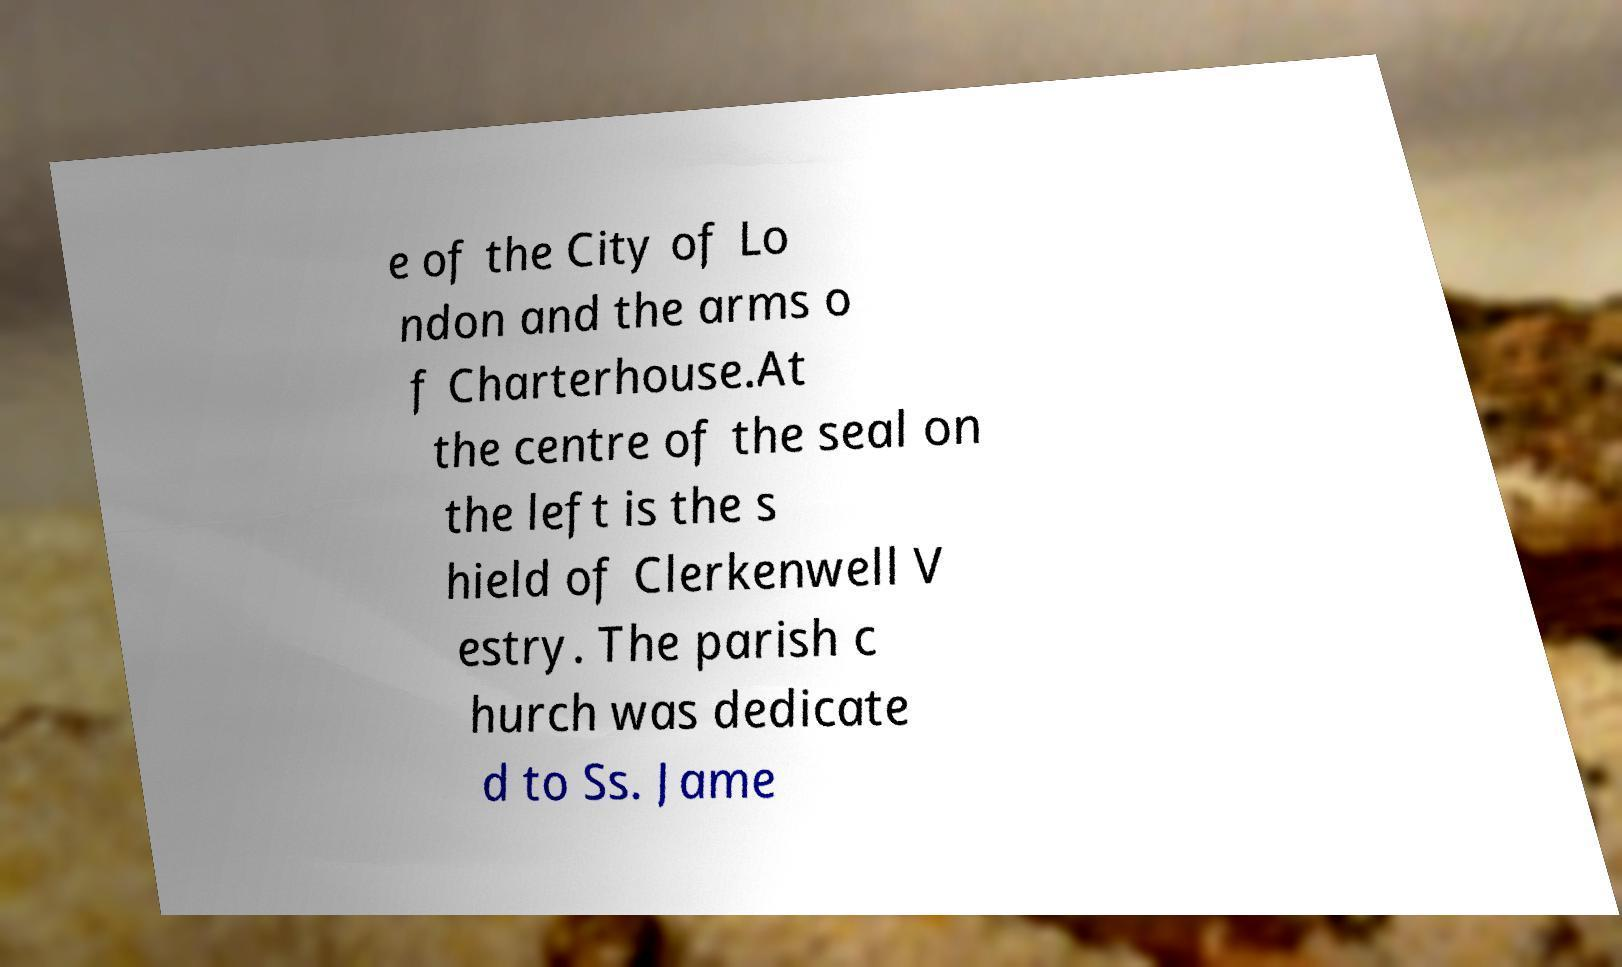For documentation purposes, I need the text within this image transcribed. Could you provide that? e of the City of Lo ndon and the arms o f Charterhouse.At the centre of the seal on the left is the s hield of Clerkenwell V estry. The parish c hurch was dedicate d to Ss. Jame 